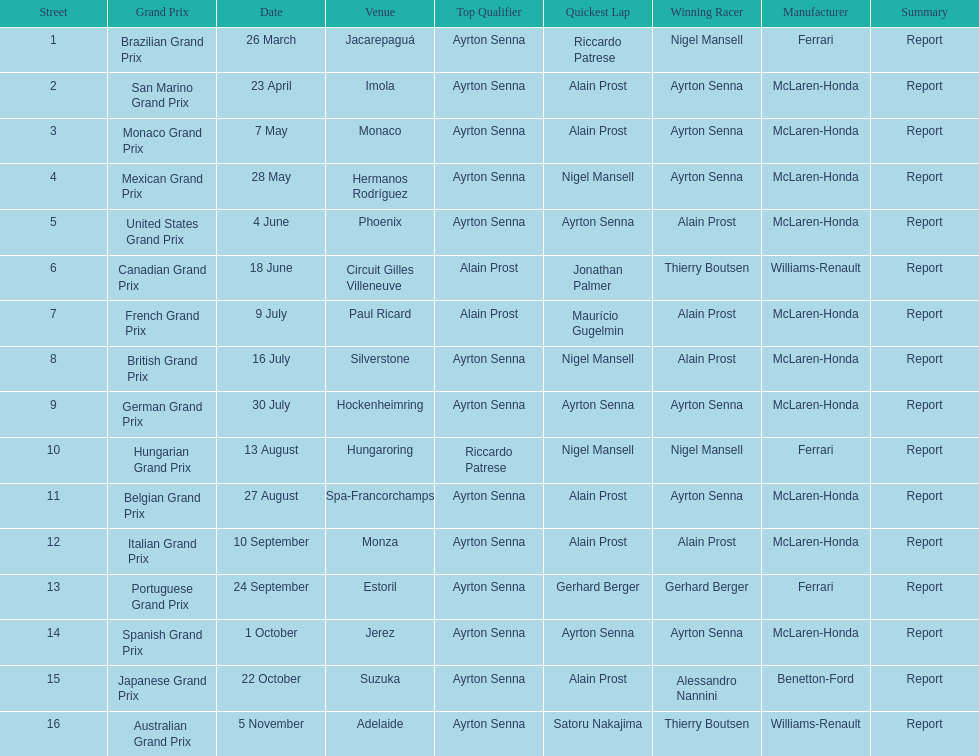How many times did alain prost achieve the fastest lap? 5. 